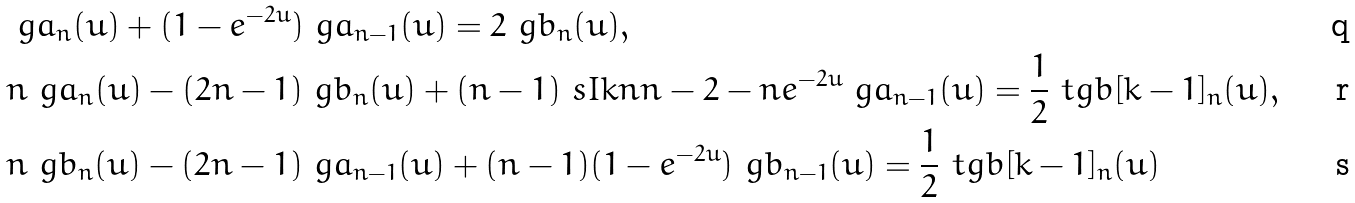<formula> <loc_0><loc_0><loc_500><loc_500>& \ g a _ { n } ( u ) + ( 1 - e ^ { - 2 u } ) \ g a _ { n - 1 } ( u ) = 2 \ g b _ { n } ( u ) , \\ & n \ g a _ { n } ( u ) - ( 2 n - 1 ) \ g b _ { n } ( u ) + ( n - 1 ) \ s I k n { n - 2 } - n e ^ { - 2 u } \ g a _ { n - 1 } ( u ) = \frac { 1 } { 2 } \ t g b [ k - 1 ] _ { n } ( u ) , \\ & n \ g b _ { n } ( u ) - ( 2 n - 1 ) \ g a _ { n - 1 } ( u ) + ( n - 1 ) ( 1 - e ^ { - 2 u } ) \ g b _ { n - 1 } ( u ) = \frac { 1 } { 2 } \ t g b [ k - 1 ] _ { n } ( u )</formula> 